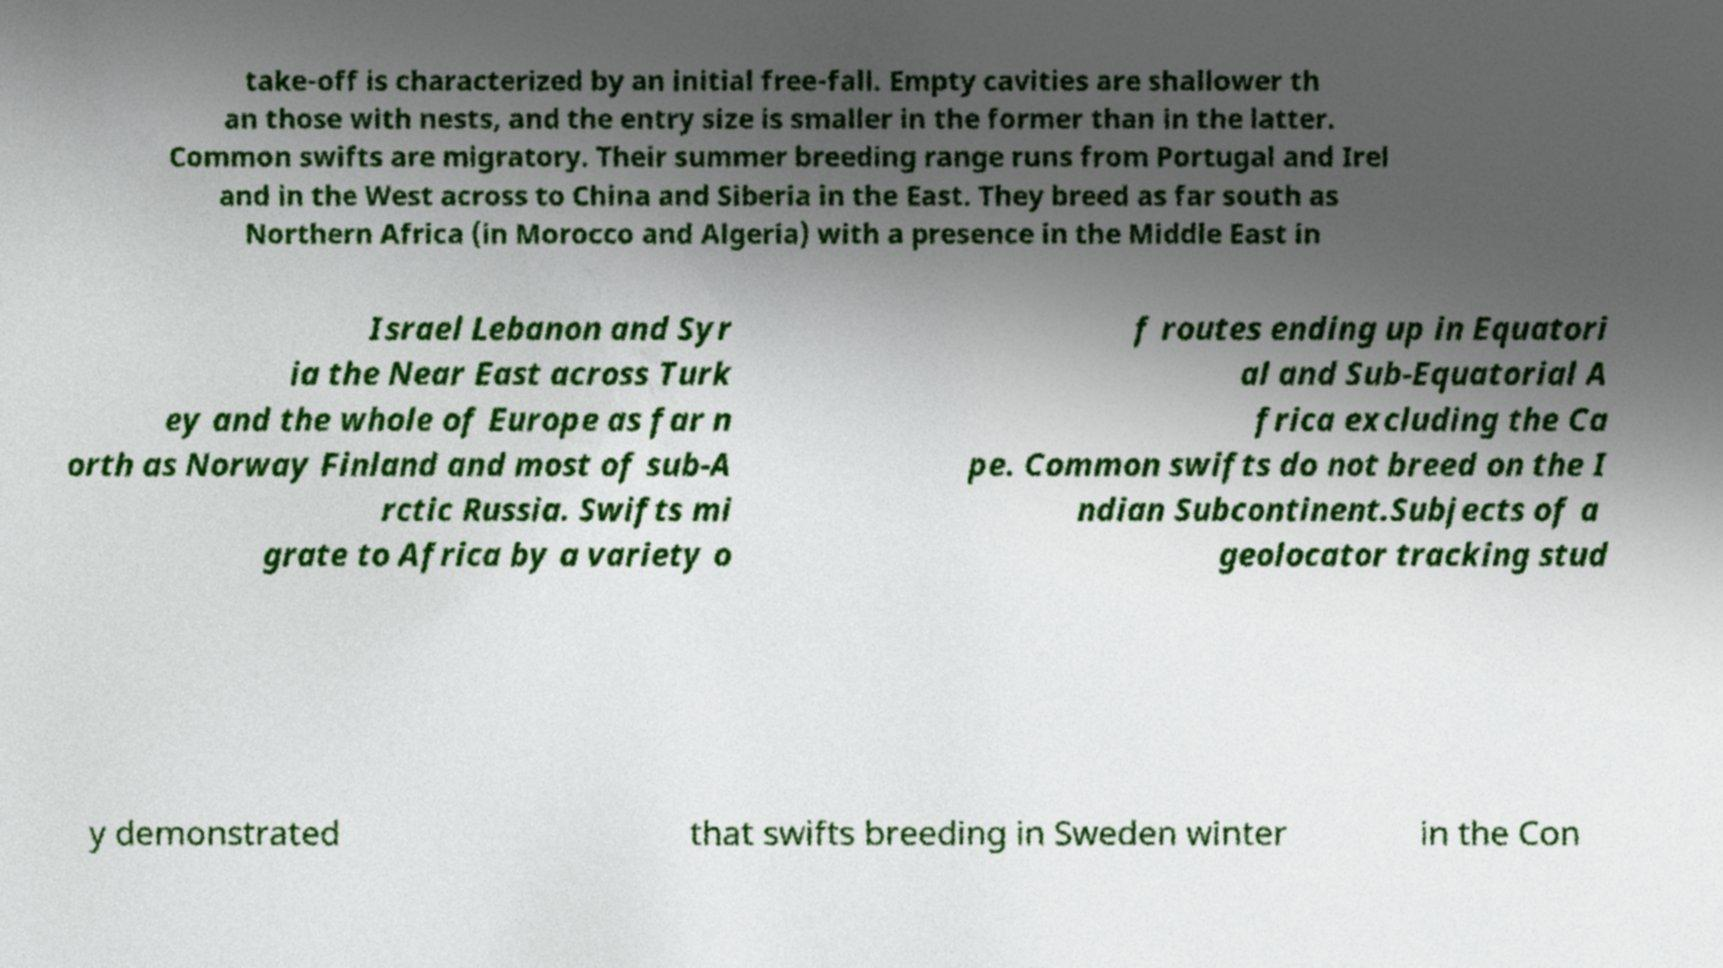What messages or text are displayed in this image? I need them in a readable, typed format. take-off is characterized by an initial free-fall. Empty cavities are shallower th an those with nests, and the entry size is smaller in the former than in the latter. Common swifts are migratory. Their summer breeding range runs from Portugal and Irel and in the West across to China and Siberia in the East. They breed as far south as Northern Africa (in Morocco and Algeria) with a presence in the Middle East in Israel Lebanon and Syr ia the Near East across Turk ey and the whole of Europe as far n orth as Norway Finland and most of sub-A rctic Russia. Swifts mi grate to Africa by a variety o f routes ending up in Equatori al and Sub-Equatorial A frica excluding the Ca pe. Common swifts do not breed on the I ndian Subcontinent.Subjects of a geolocator tracking stud y demonstrated that swifts breeding in Sweden winter in the Con 